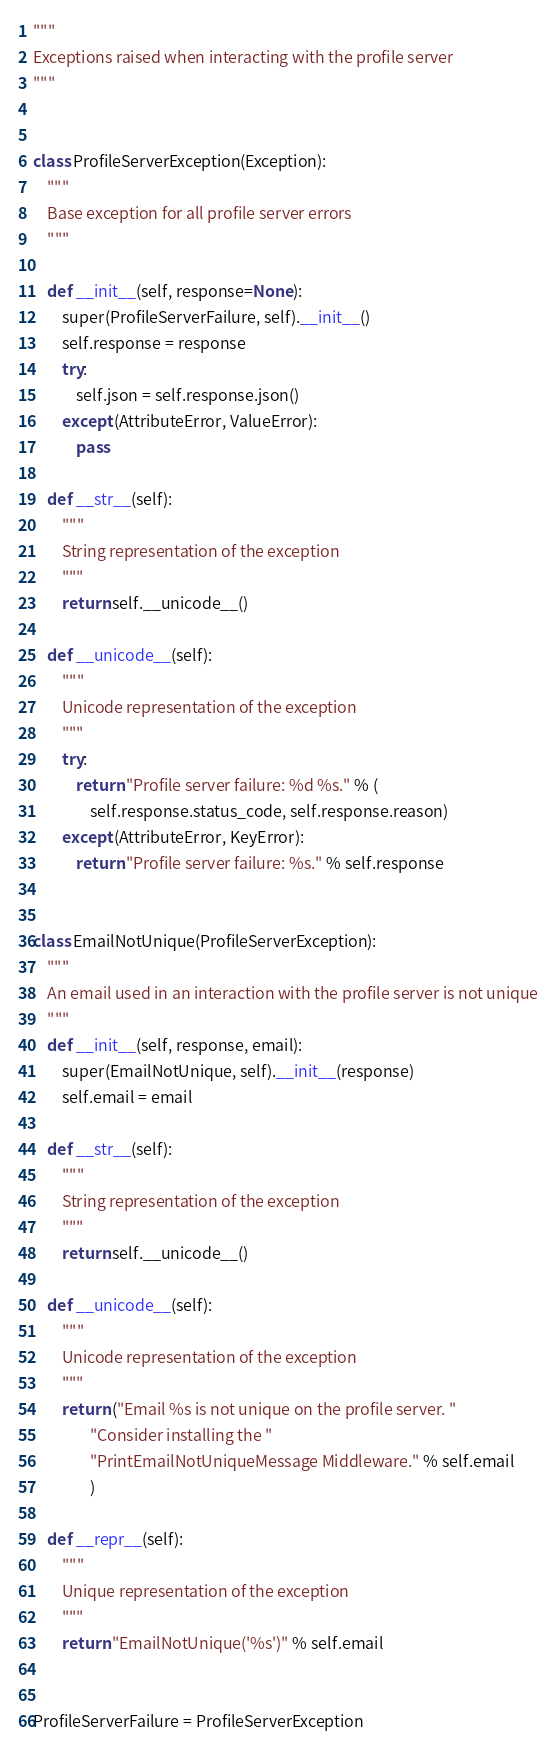Convert code to text. <code><loc_0><loc_0><loc_500><loc_500><_Python_>"""
Exceptions raised when interacting with the profile server
"""


class ProfileServerException(Exception):
    """
    Base exception for all profile server errors
    """

    def __init__(self, response=None):
        super(ProfileServerFailure, self).__init__()
        self.response = response
        try:
            self.json = self.response.json()
        except (AttributeError, ValueError):
            pass

    def __str__(self):
        """
        String representation of the exception
        """
        return self.__unicode__()

    def __unicode__(self):
        """
        Unicode representation of the exception
        """
        try:
            return "Profile server failure: %d %s." % (
                self.response.status_code, self.response.reason)
        except (AttributeError, KeyError):
            return "Profile server failure: %s." % self.response


class EmailNotUnique(ProfileServerException):
    """
    An email used in an interaction with the profile server is not unique
    """
    def __init__(self, response, email):
        super(EmailNotUnique, self).__init__(response)
        self.email = email

    def __str__(self):
        """
        String representation of the exception
        """
        return self.__unicode__()

    def __unicode__(self):
        """
        Unicode representation of the exception
        """
        return ("Email %s is not unique on the profile server. "
                "Consider installing the "
                "PrintEmailNotUniqueMessage Middleware." % self.email
                )

    def __repr__(self):
        """
        Unique representation of the exception
        """
        return "EmailNotUnique('%s')" % self.email


ProfileServerFailure = ProfileServerException
</code> 